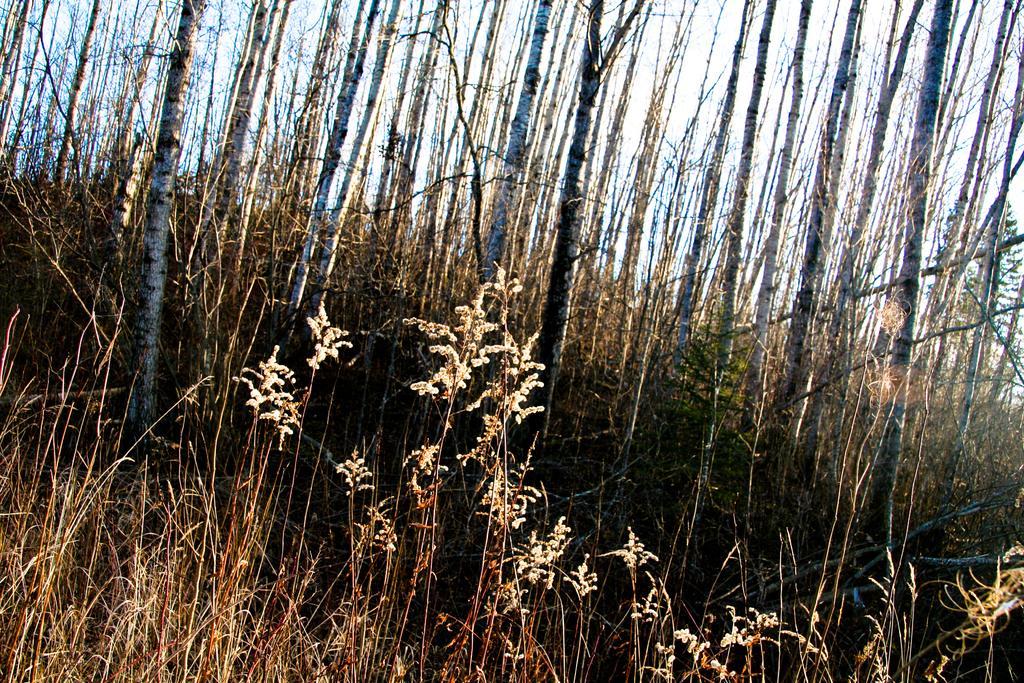Describe this image in one or two sentences. In this image we can see some plants and bamboo trees. 